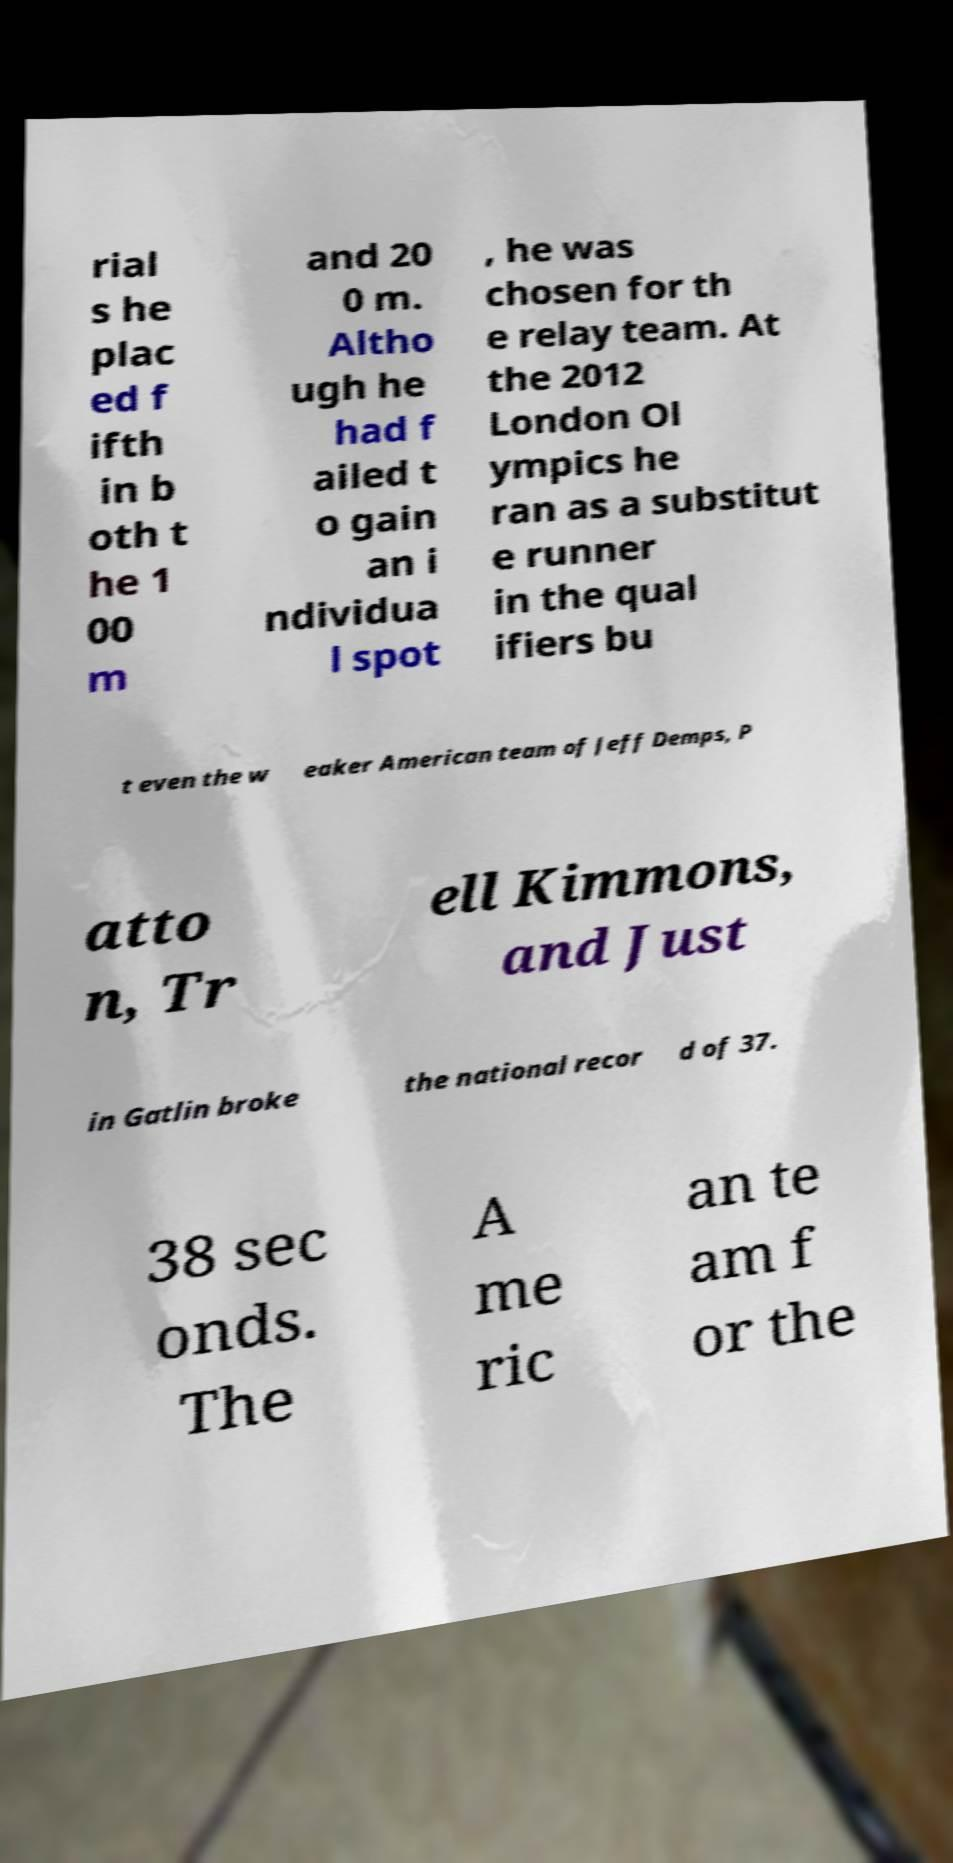There's text embedded in this image that I need extracted. Can you transcribe it verbatim? rial s he plac ed f ifth in b oth t he 1 00 m and 20 0 m. Altho ugh he had f ailed t o gain an i ndividua l spot , he was chosen for th e relay team. At the 2012 London Ol ympics he ran as a substitut e runner in the qual ifiers bu t even the w eaker American team of Jeff Demps, P atto n, Tr ell Kimmons, and Just in Gatlin broke the national recor d of 37. 38 sec onds. The A me ric an te am f or the 